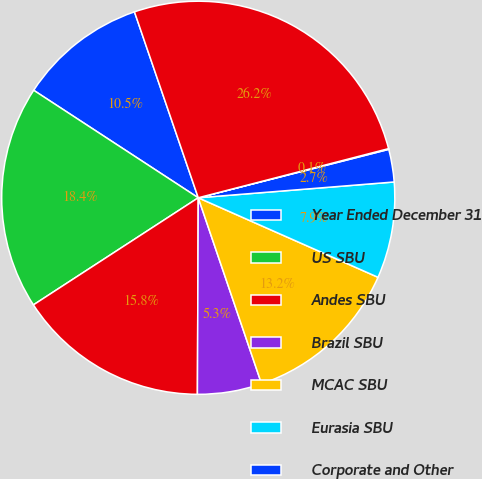Convert chart. <chart><loc_0><loc_0><loc_500><loc_500><pie_chart><fcel>Year Ended December 31<fcel>US SBU<fcel>Andes SBU<fcel>Brazil SBU<fcel>MCAC SBU<fcel>Eurasia SBU<fcel>Corporate and Other<fcel>Eliminations<fcel>Total Revenue<nl><fcel>10.53%<fcel>18.38%<fcel>15.76%<fcel>5.29%<fcel>13.15%<fcel>7.91%<fcel>2.68%<fcel>0.06%<fcel>26.24%<nl></chart> 